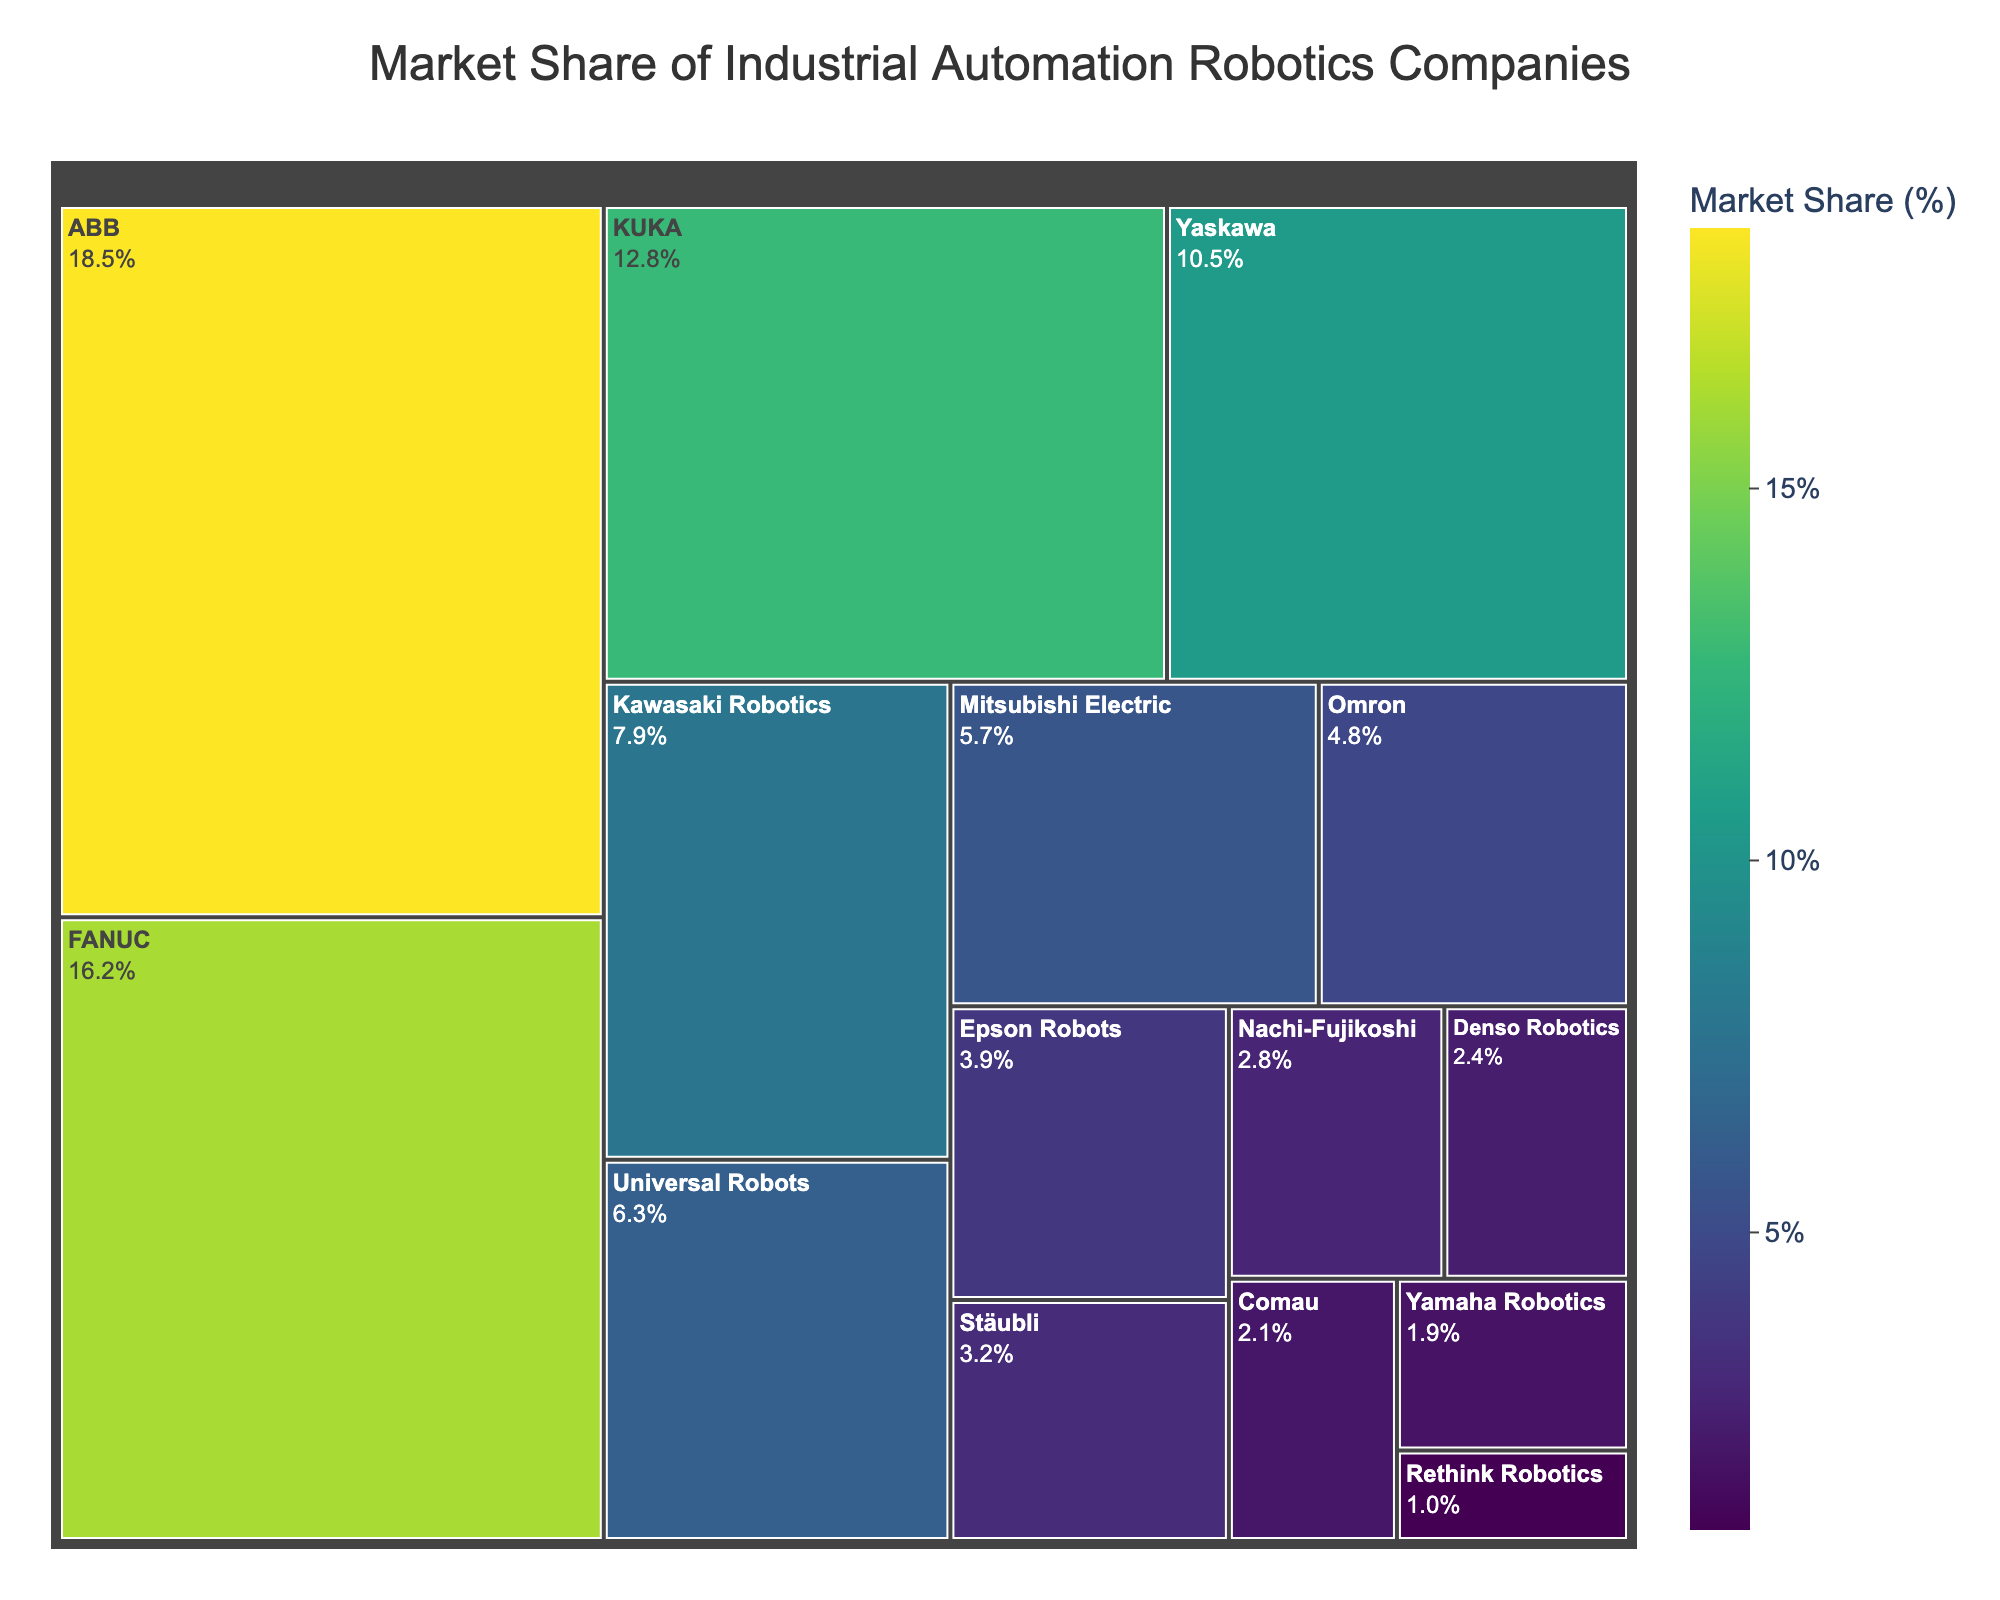What's the largest market share among the companies? By examining the size of the blocks in the treemap, we can identify the company with the largest market share as the largest block. The label will show the company name and its market share.
Answer: 18.5% How many companies have a market share greater than 10%? By counting the blocks with a market share percentage written on them greater than 10%, we identify the companies meeting this criterion.
Answer: 4 Which company has the smallest market share? The smallest block on the treemap will indicate the company with the smallest market share.
Answer: Rethink Robotics What is the total market share of the top three companies combined? Adding the market shares of the top three companies (18.5% for ABB, 16.2% for FANUC, and 12.8% for KUKA) gives us the total market share.
Answer: 47.5% Is the market share of FANUC closer to ABB or KUKA? By comparing the differences in market share: FANUC to ABB (18.5% - 16.2% = 2.3%) and FANUC to KUKA (16.2% - 12.8% = 3.4%), it becomes clear which difference is smaller.
Answer: ABB What color spectrum is used to represent the market shares in the treemap? By noting the color shading on the treemap and recognizing the utilization of various shades, it is identifiable as the 'viridis' color scale.
Answer: Viridis Which company has a market share just under 10%? By reviewing the treemap for companies near the 10% mark and identifying the one with slightly less, we can find the answer.
Answer: Yaskawa Between Kawasaki Robotics and Universal Robots, which has a higher market share? By comparing the market share percentages of Kawasaki Robotics (7.9%) and Universal Robots (6.3%) directly as shown in the treemap, it is clear which is higher.
Answer: Kawasaki Robotics What's the combined market share of companies with less than 5% each? Adding the market shares of Omron (4.8%), Epson Robots (3.9%), Stäubli (3.2%), Nachi-Fujikoshi (2.8%), Denso Robotics (2.4%), Comau (2.1%), Yamaha Robotics (1.9%), and Rethink Robotics (1.0%) yields the total.
Answer: 22.1% Does any company have a perfect 5% market share? By examining each block's label in the treemap, checking for a value exactly equal to 5%, we can determine if any company meets this criterion.
Answer: No 